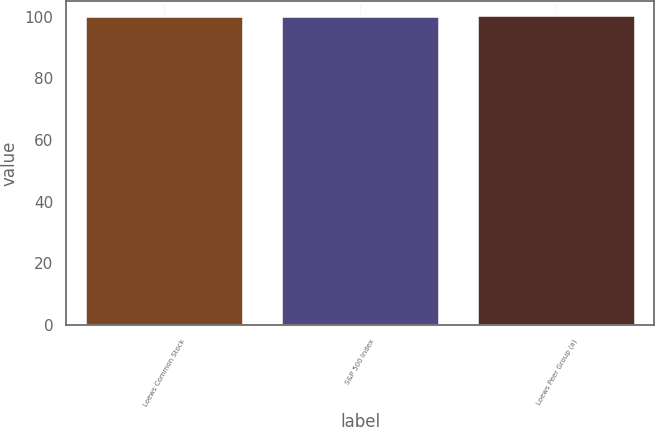Convert chart. <chart><loc_0><loc_0><loc_500><loc_500><bar_chart><fcel>Loews Common Stock<fcel>S&P 500 Index<fcel>Loews Peer Group (a)<nl><fcel>100<fcel>100.1<fcel>100.2<nl></chart> 